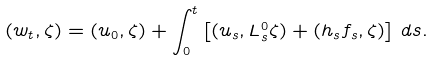<formula> <loc_0><loc_0><loc_500><loc_500>( w _ { t } , \zeta ) = ( u _ { 0 } , \zeta ) + \int _ { 0 } ^ { t } \left [ ( u _ { s } , L ^ { 0 } _ { s } \zeta ) + ( h _ { s } f _ { s } , \zeta ) \right ] \, d s .</formula> 